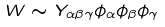<formula> <loc_0><loc_0><loc_500><loc_500>W \sim Y _ { \alpha \beta \gamma } \phi _ { \alpha } \phi _ { \beta } \phi _ { \gamma }</formula> 